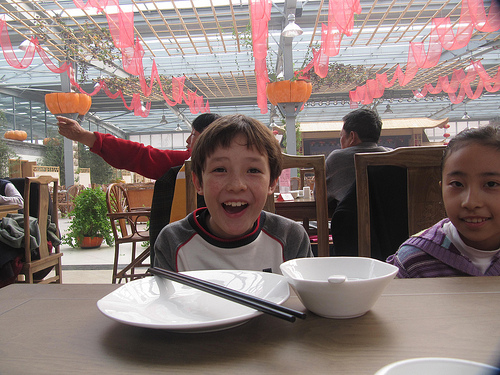<image>
Is there a chopsticks on the table? No. The chopsticks is not positioned on the table. They may be near each other, but the chopsticks is not supported by or resting on top of the table. 